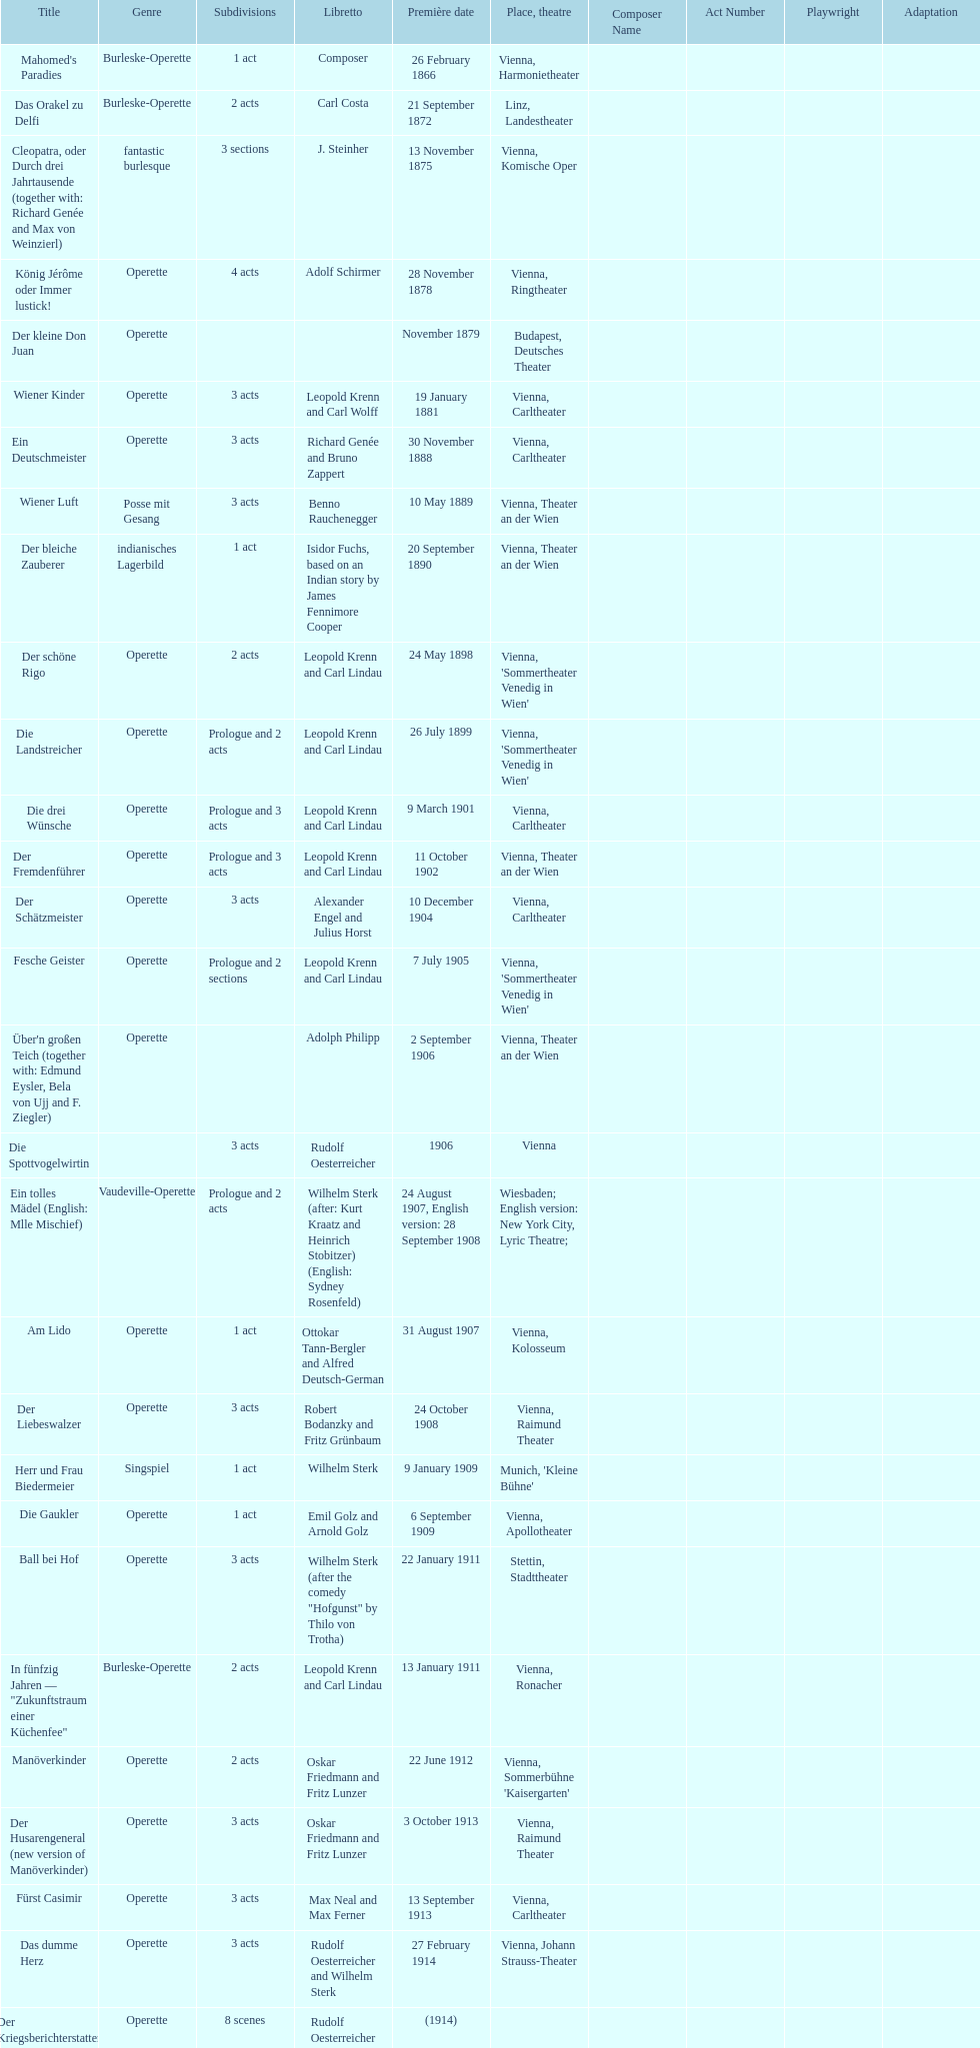What was the year of the last title? 1958. 